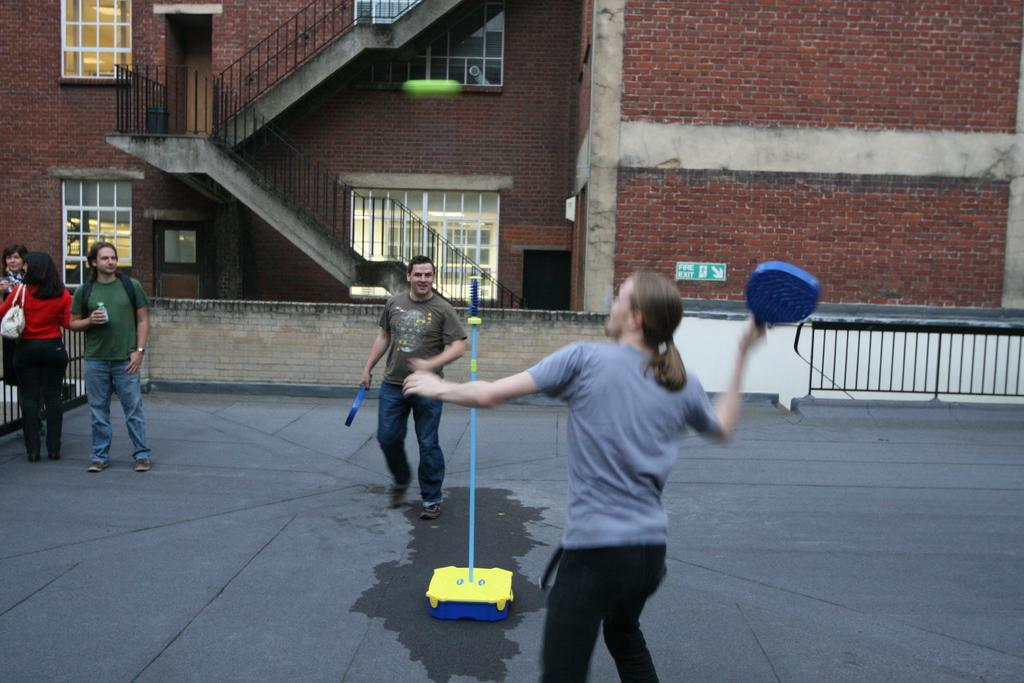What type of structures can be seen in the image? There are buildings in the image. What architectural features are visible on the buildings? There are windows and stairs visible on the buildings. Are there any living beings present in the image? Yes, there are people present in the image. What type of bird can be seen flying with a wing in the image? There is no bird or wing present in the image. Can you describe the truck that is parked near the buildings in the image? There is no truck present in the image; only buildings, windows, stairs, and people are visible. 